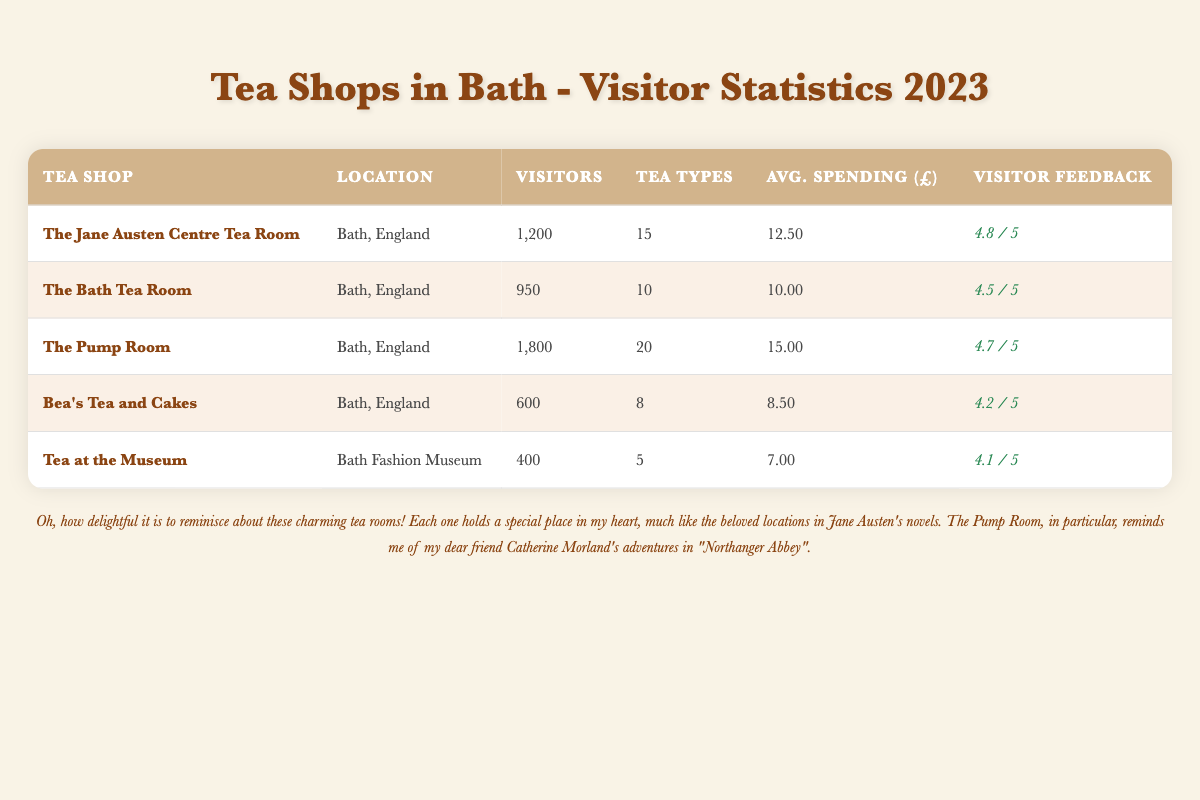What is the visitor count for The Jane Austen Centre Tea Room? According to the table, The Jane Austen Centre Tea Room has a visitor count of 1,200.
Answer: 1,200 Which tea shop has the highest visitor count? The table shows that The Pump Room has the highest visitor count at 1,800 visitors.
Answer: The Pump Room What is the average spending per visitor at Bea's Tea and Cakes? Bea's Tea and Cakes reports an average spending of £8.50 per visitor.
Answer: £8.50 How many tea types are sold at The Bath Tea Room? The Bath Tea Room sells 10 different types of tea, as stated in the table.
Answer: 10 Is the visitor feedback rating for Tea at the Museum higher than 4.0? The table indicates that Tea at the Museum has a visitor feedback rating of 4.1, which is indeed higher than 4.0.
Answer: Yes What is the total number of visitors across all tea shops listed? To find the total, we sum the visitor counts: 1200 + 950 + 1800 + 600 + 400 = 3950. Therefore, the total number of visitors is 3,950.
Answer: 3,950 Which tea shop has the highest average spending? The table reveals that The Pump Room has the highest average spending at £15.00 per visitor.
Answer: The Pump Room What is the difference in visitor count between the most and least visited tea shops? The most visited tea shop is The Pump Room with 1,800 visitors, and the least visited is Tea at the Museum with 400 visitors. The difference is 1,800 - 400 = 1,400.
Answer: 1,400 Do any of the tea shops have a visitor feedback score of 4.6 or higher? Yes, both The Jane Austen Centre Tea Room and The Pump Room have feedback scores of 4.8 and 4.7, respectively, which are higher than 4.6.
Answer: Yes 